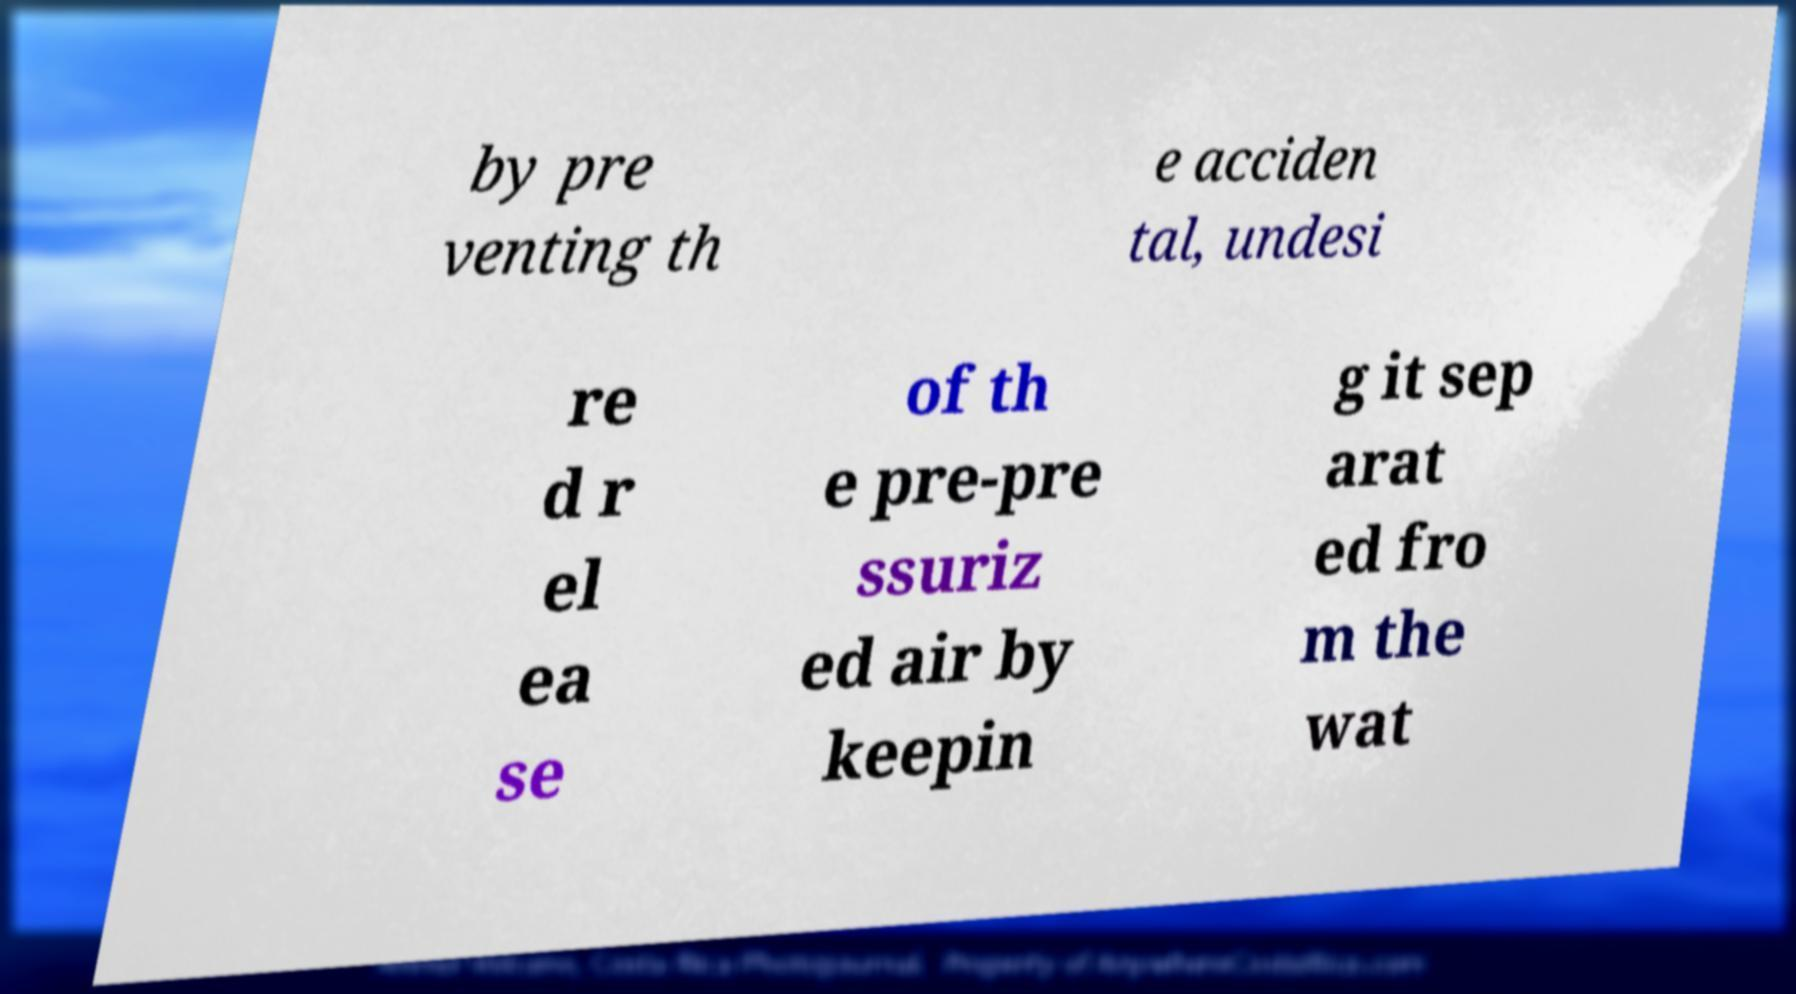Can you read and provide the text displayed in the image?This photo seems to have some interesting text. Can you extract and type it out for me? by pre venting th e acciden tal, undesi re d r el ea se of th e pre-pre ssuriz ed air by keepin g it sep arat ed fro m the wat 